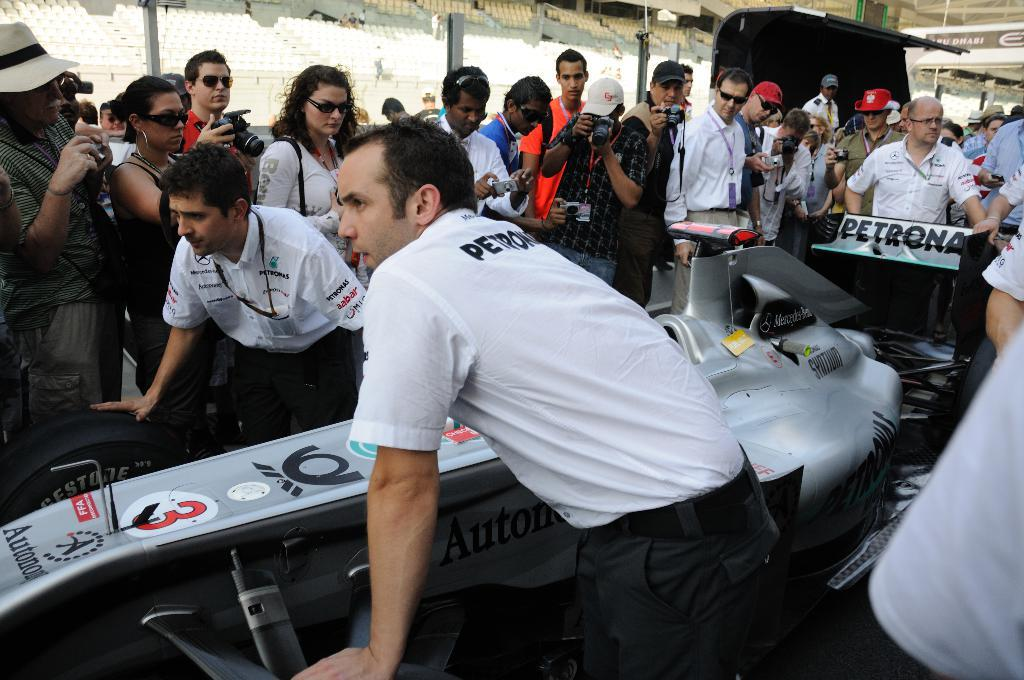How many people are present in the image? There are many people in the image. What accessories are some people wearing in the image? Some people are wearing caps and goggles in the image. What are some people holding in the image? Some people are holding cameras in the image. What vehicle can be seen in the image? There is a car in the image. What type of furniture is visible in the background of the image? There are chairs in the background of the image. What team is responsible for causing the car to move in the image? There is no team present in the image, and the car's movement is not mentioned. Additionally, the cause of the car's movement is not visible in the image. 